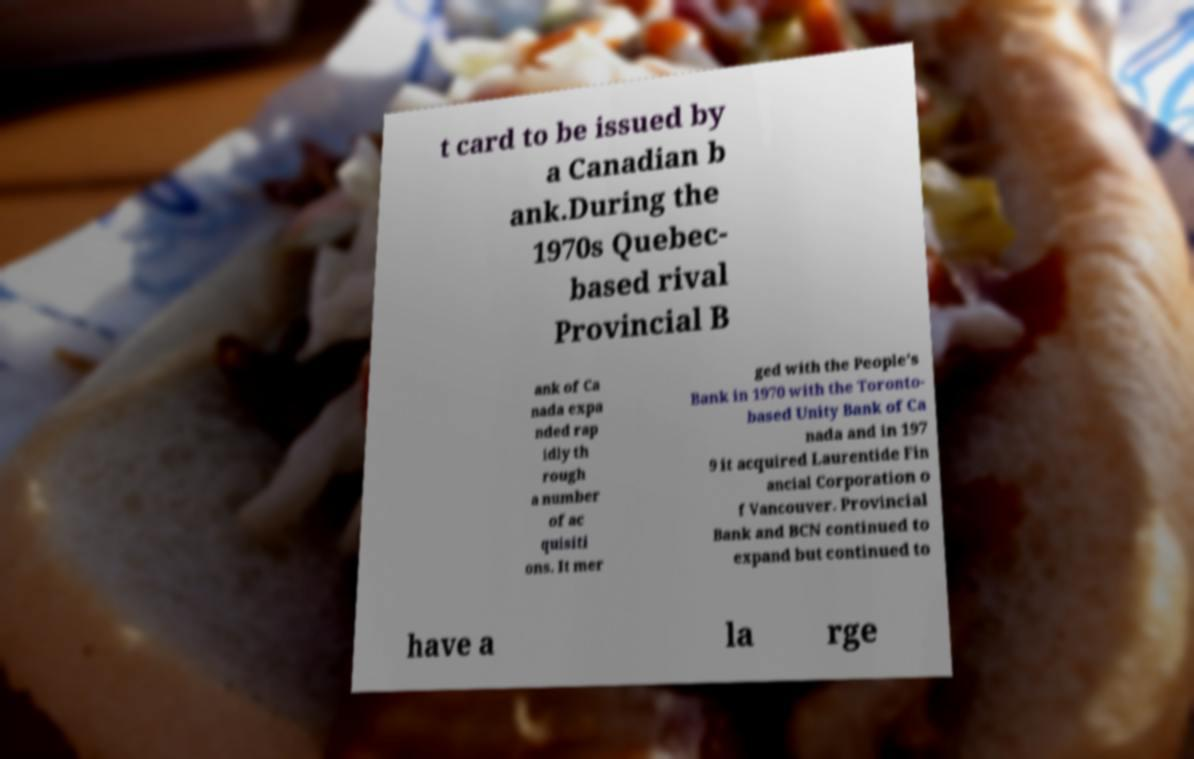What messages or text are displayed in this image? I need them in a readable, typed format. t card to be issued by a Canadian b ank.During the 1970s Quebec- based rival Provincial B ank of Ca nada expa nded rap idly th rough a number of ac quisiti ons. It mer ged with the People's Bank in 1970 with the Toronto- based Unity Bank of Ca nada and in 197 9 it acquired Laurentide Fin ancial Corporation o f Vancouver. Provincial Bank and BCN continued to expand but continued to have a la rge 